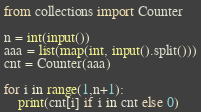<code> <loc_0><loc_0><loc_500><loc_500><_Python_>from collections import Counter

n = int(input())
aaa = list(map(int, input().split()))
cnt = Counter(aaa)

for i in range(1,n+1):
    print(cnt[i] if i in cnt else 0)
</code> 